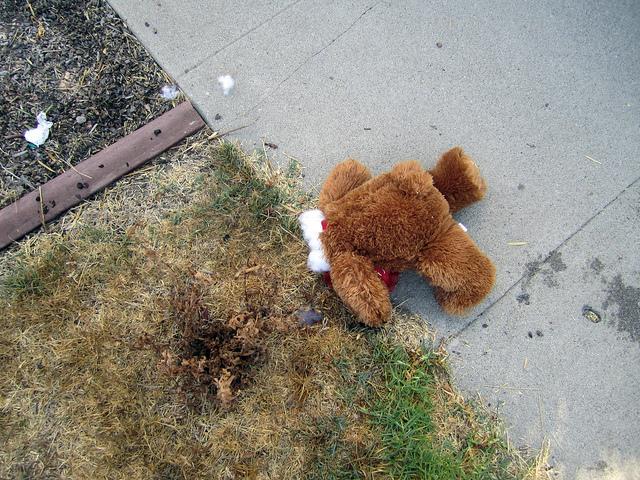Does this bear have a head?
Concise answer only. No. What is the sidewalk made of?
Be succinct. Concrete. Why is the teddy bear laying on the sidewalk?
Keep it brief. Abandoned. 